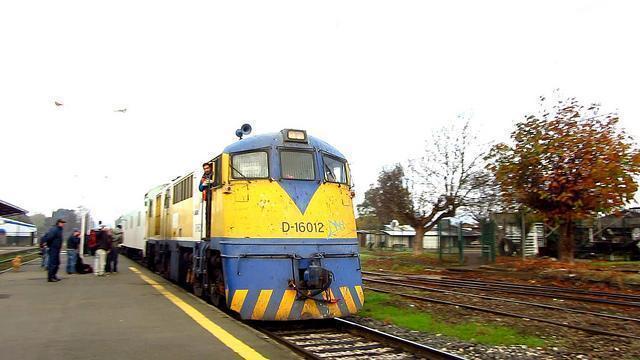What are the people waiting to do?
Indicate the correct response by choosing from the four available options to answer the question.
Options: Pay, eat, play, board. Board. 